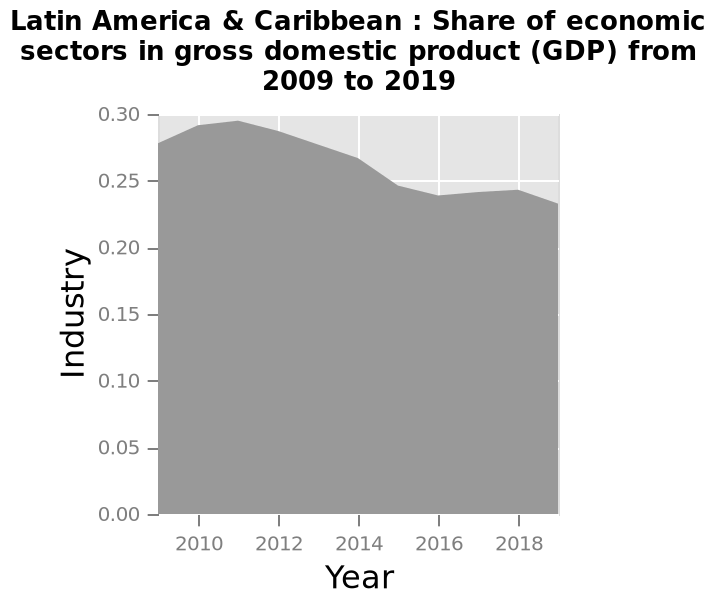<image>
Did the share of GDP increase or decrease between 2009 and 2011?  The share of GDP increased between 2009 and 2011. please summary the statistics and relations of the chart The share of GDP increased between 2009 and 2011. There was a decrease in the share of GDP between 2011 and 2016. There was a slight increase in the share of GDP between 2016 and 2018. There was a decrease in the share of GDP between 2018 and 2019. 